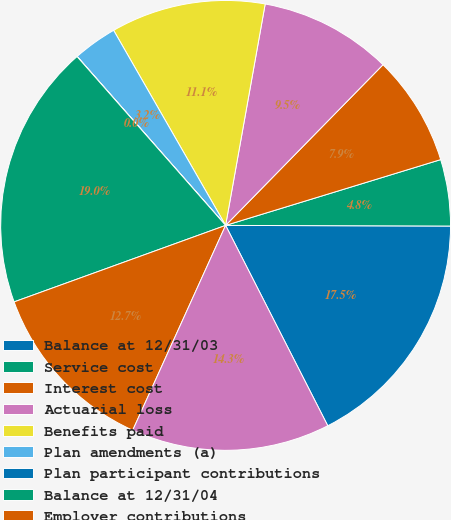<chart> <loc_0><loc_0><loc_500><loc_500><pie_chart><fcel>Balance at 12/31/03<fcel>Service cost<fcel>Interest cost<fcel>Actuarial loss<fcel>Benefits paid<fcel>Plan amendments (a)<fcel>Plan participant contributions<fcel>Balance at 12/31/04<fcel>Employer contributions<fcel>Funded status<nl><fcel>17.45%<fcel>4.77%<fcel>7.94%<fcel>9.52%<fcel>11.11%<fcel>3.18%<fcel>0.01%<fcel>19.04%<fcel>12.7%<fcel>14.28%<nl></chart> 